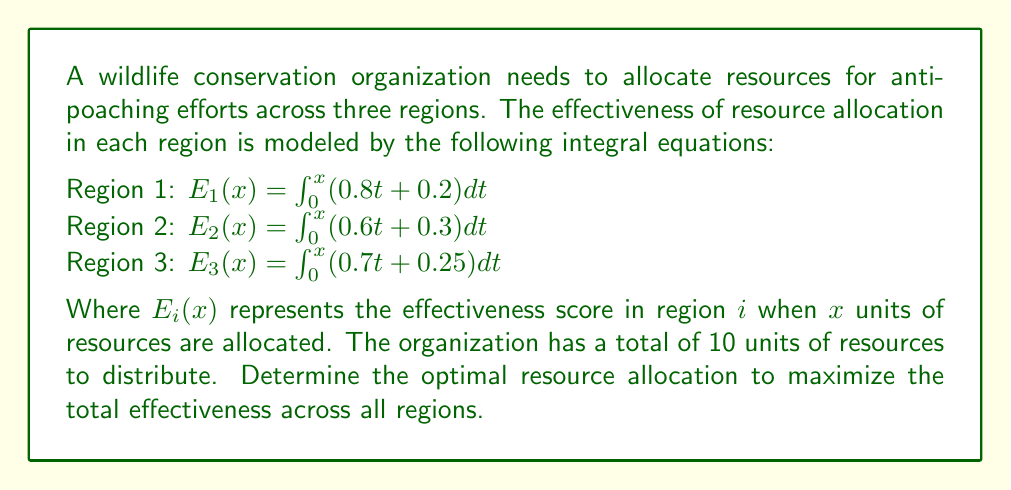Provide a solution to this math problem. To solve this problem, we'll follow these steps:

1) First, we need to evaluate the integrals for each region:

   Region 1: $E_1(x) = \int_0^x (0.8t + 0.2)dt = 0.4x^2 + 0.2x$
   Region 2: $E_2(x) = \int_0^x (0.6t + 0.3)dt = 0.3x^2 + 0.3x$
   Region 3: $E_3(x) = \int_0^x (0.7t + 0.25)dt = 0.35x^2 + 0.25x$

2) Let $x_1$, $x_2$, and $x_3$ be the resources allocated to regions 1, 2, and 3 respectively. We want to maximize:

   $E_{total} = E_1(x_1) + E_2(x_2) + E_3(x_3)$

3) Subject to the constraint: $x_1 + x_2 + x_3 = 10$

4) To optimize this, we use the method of Lagrange multipliers. Let's define:

   $L(x_1, x_2, x_3, \lambda) = E_1(x_1) + E_2(x_2) + E_3(x_3) - \lambda(x_1 + x_2 + x_3 - 10)$

5) Now, we set the partial derivatives equal to zero:

   $\frac{\partial L}{\partial x_1} = 0.8x_1 + 0.2 - \lambda = 0$
   $\frac{\partial L}{\partial x_2} = 0.6x_2 + 0.3 - \lambda = 0$
   $\frac{\partial L}{\partial x_3} = 0.7x_3 + 0.25 - \lambda = 0$
   $\frac{\partial L}{\partial \lambda} = x_1 + x_2 + x_3 - 10 = 0$

6) From these equations, we can derive:

   $x_1 = \frac{\lambda - 0.2}{0.8}$
   $x_2 = \frac{\lambda - 0.3}{0.6}$
   $x_3 = \frac{\lambda - 0.25}{0.7}$

7) Substituting these into the constraint equation:

   $\frac{\lambda - 0.2}{0.8} + \frac{\lambda - 0.3}{0.6} + \frac{\lambda - 0.25}{0.7} = 10$

8) Solving this equation gives us $\lambda \approx 0.9643$

9) Substituting this value back into the equations for $x_1$, $x_2$, and $x_3$:

   $x_1 \approx 3.80$
   $x_2 \approx 3.31$
   $x_3 \approx 2.89$

10) Rounding to the nearest tenth for practical implementation:

    $x_1 = 3.8$
    $x_2 = 3.3$
    $x_3 = 2.9$
Answer: Region 1: 3.8 units, Region 2: 3.3 units, Region 3: 2.9 units 